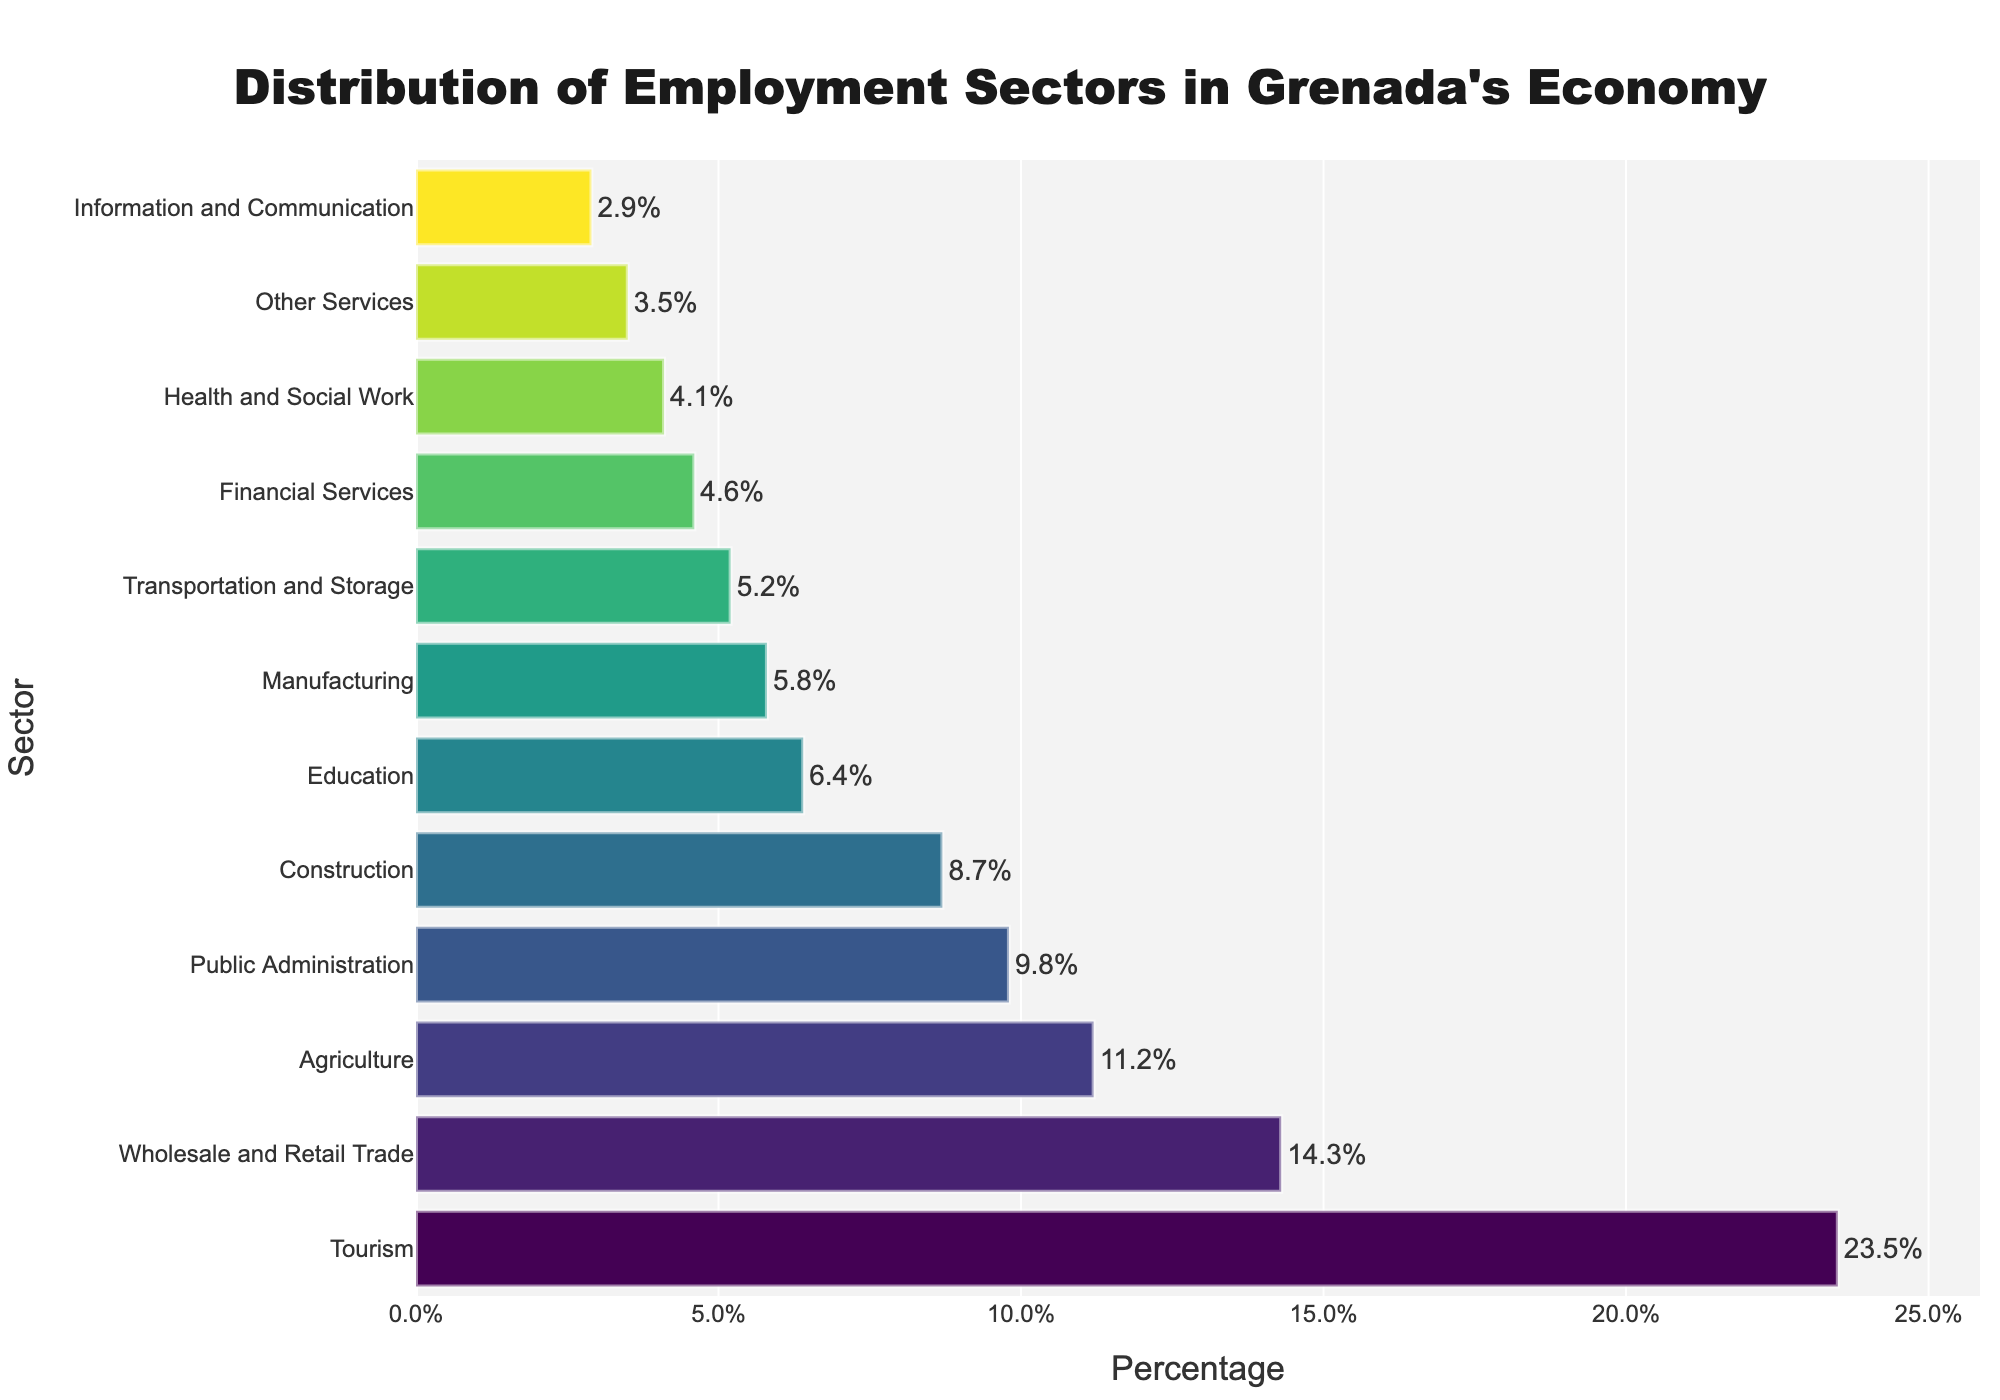Which sector has the largest percentage in Grenada's economy? The bar for the Tourism sector is the longest and positioned at the top when sorted by percentage, indicating it has the largest percentage.
Answer: Tourism What is the combined percentage of Agriculture and Manufacturing sectors? The percentage for Agriculture is 11.2% and for Manufacturing is 5.8%. Summing them up: 11.2 + 5.8 = 17.0%
Answer: 17.0% Which sectors have a percentage less than 5%? By observing the lengths of the bars, the sectors Information and Communication (2.9%), Financial Services (4.6%), Health and Social Work (4.1%), Other Services (3.5%), and Transportation and Storage (5.2%) are less than 5%.
Answer: Information and Communication, Financial Services, Health and Social Work, Other Services How much higher is the percentage for Tourism compared to Public Administration? The percentage for Tourism is 23.5% and for Public Administration is 9.8%. Subtracting them: 23.5 - 9.8 = 13.7%
Answer: 13.7% What is the average percentage share of the sectors: Construction, Wholesale and Retail Trade, and Education? Construction is 8.7%, Wholesale and Retail Trade is 14.3%, and Education is 6.4%. Summing them: 8.7 + 14.3 + 6.4 = 29.4%. Dividing by the number of sectors: 29.4 / 3 ≈ 9.8%
Answer: 9.8% Which sector has a longer bar: Health and Social Work or Financial Services? Comparing the bars visually, Financial Services (4.6%) has a longer bar than Health and Social Work (4.1%).
Answer: Financial Services What percentage of employment is in sectors with 'Services' in their names? (Financial Services, Health and Social Work, Other Services) Financial Services is 4.6%, Health and Social Work is 4.1%, and Other Services is 3.5%. Summing them up: 4.6 + 4.1 + 3.5 = 12.2%
Answer: 12.2% Is the percentage for Wholesale and Retail Trade greater than twice the percentage for Manufacturing? The percentage for Wholesale and Retail Trade is 14.3%, and for Manufacturing is 5.8%. Twice of Manufacturing is: 2 * 5.8 = 11.6%. Since 14.3 > 11.6, the percentage is greater.
Answer: Yes Which sector's percentage is closest to the median value of all listed sectors' percentages? When sorted, the percentages are: 2.9, 3.5, 4.1, 4.6, 5.2, 5.8, 6.4, 8.7, 9.8, 11.2, 14.3, 23.5. The median is the average of the 6th and 7th values: (5.8 + 6.4)/2 = 6.1%. The sector closest to 6.1% is Education at 6.4%.
Answer: Education 